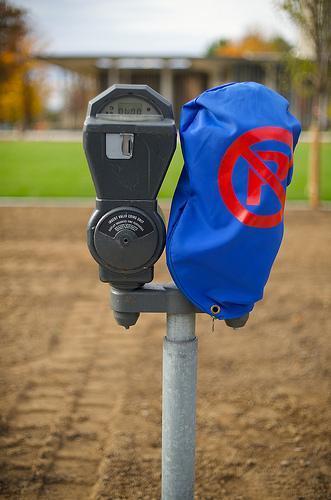How many working meters are visible?
Give a very brief answer. 1. 